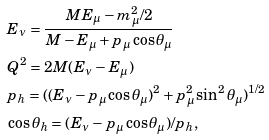Convert formula to latex. <formula><loc_0><loc_0><loc_500><loc_500>& E _ { \nu } = \frac { M E _ { \mu } - m _ { \mu } ^ { 2 } / 2 } { M - E _ { \mu } + p _ { \mu } \cos \theta _ { \mu } } \\ & Q ^ { 2 } = 2 M ( E _ { \nu } - E _ { \mu } ) \\ & p _ { h } = ( ( E _ { \nu } - p _ { \mu } \cos \theta _ { \mu } ) ^ { 2 } + p _ { \mu } ^ { 2 } \sin ^ { 2 } \theta _ { \mu } ) ^ { 1 / 2 } \\ & \cos \theta _ { h } = ( E _ { \nu } - p _ { \mu } \cos \theta _ { \mu } ) / p _ { h } ,</formula> 